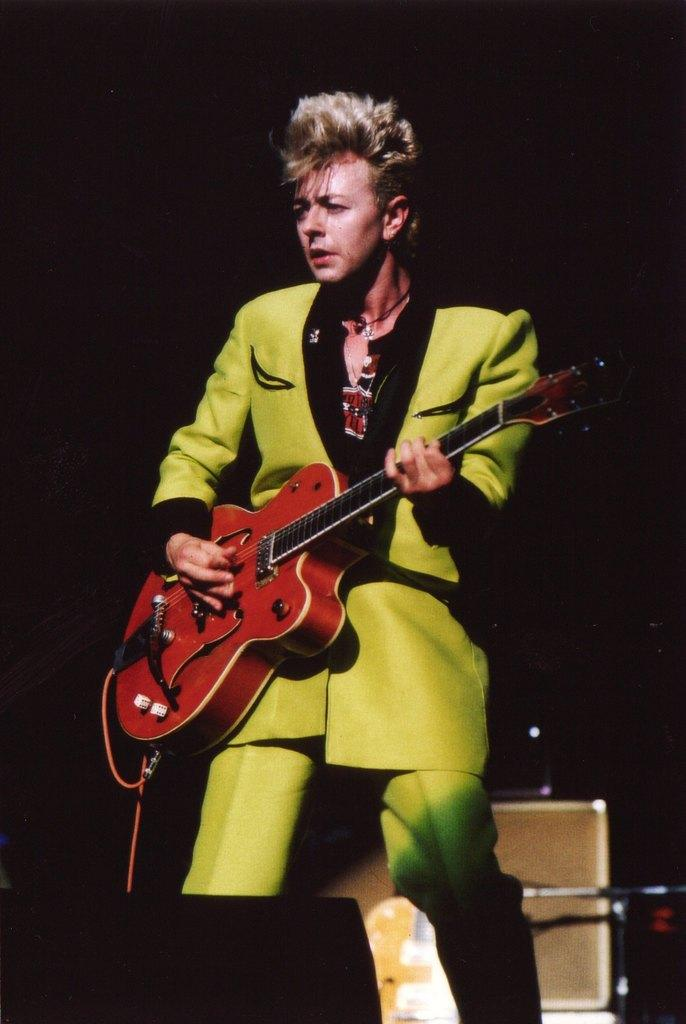What is the man in the image doing? The man is playing the guitar. What is the man holding in the image? The man is holding a guitar. Where is the man standing in the image? The man is standing on a dais. What is the man looking at in the image? The man is looking at something else. What can be seen in the background of the image? There are musical instruments in the backdrop of the image. How many tomatoes can be seen in the image? There are no tomatoes present in the image. What type of art is displayed on the wall behind the man? There is no art displayed on the wall behind the man in the image. 